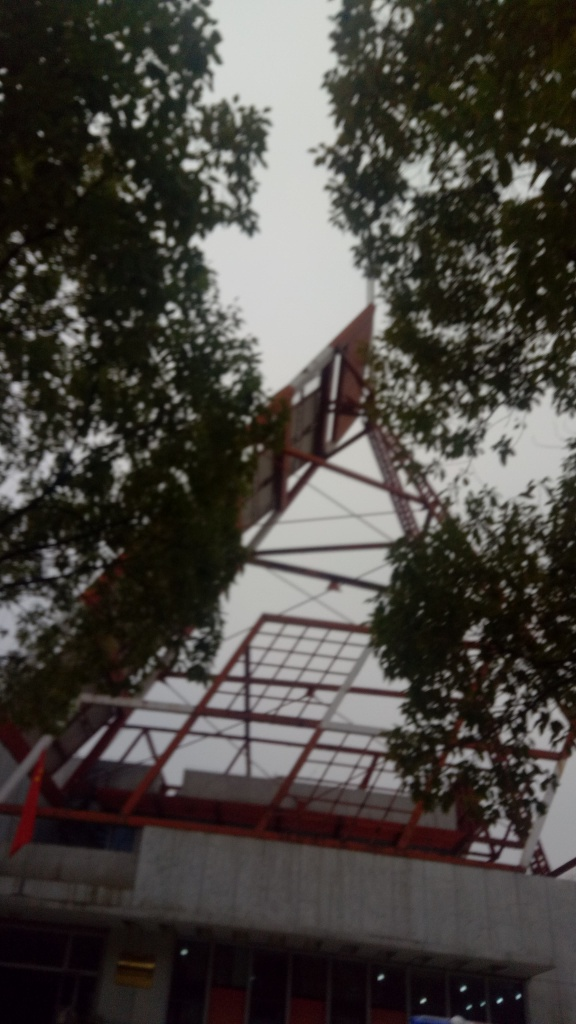Can you describe the weather or time of day this photo was taken? The sky in the background is overcast, with no discernible shadows, suggesting an absence of direct sunlight. This, along with the diffused light, might indicate that the photo was taken on a cloudy day or during a time when the sun is not at its peak brightness, such as in the morning or late afternoon. 